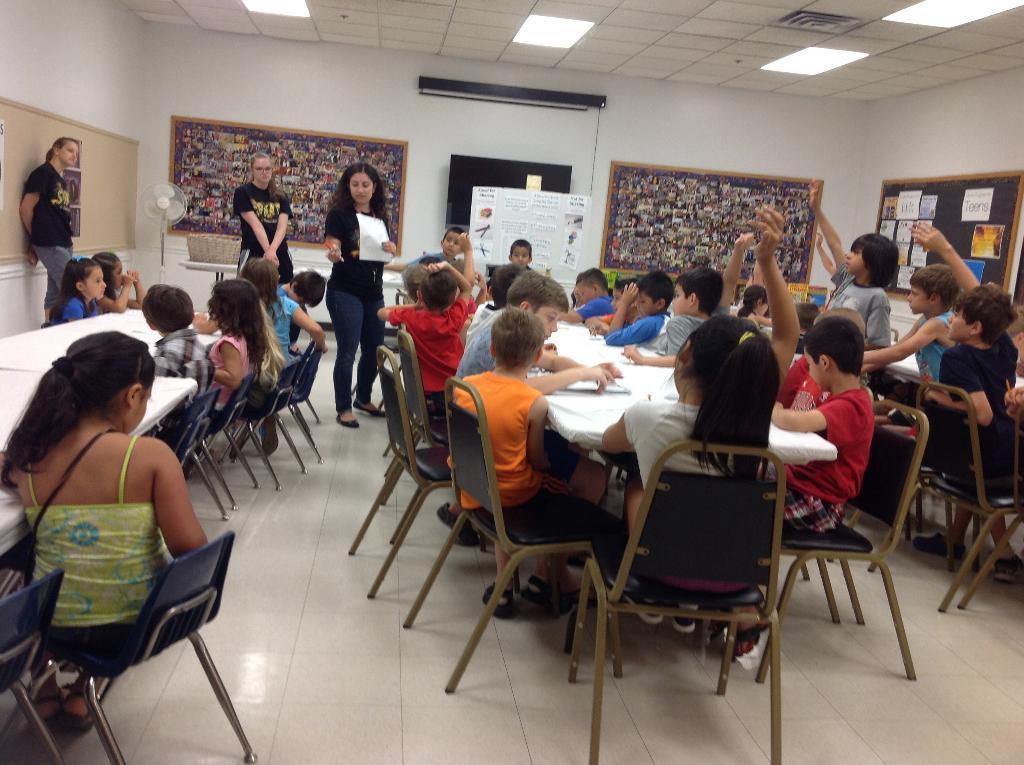Can you describe this image briefly? In this picture we can see three woman standing where one is holding paper in his hand and in front of them we can see a group of children sitting on chairs and on table we have papers and in background we can see wall with boards. 